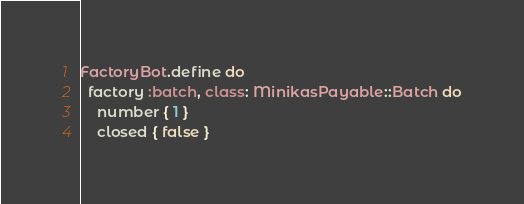Convert code to text. <code><loc_0><loc_0><loc_500><loc_500><_Ruby_>FactoryBot.define do
  factory :batch, class: MinikasPayable::Batch do
    number { 1 }
    closed { false }</code> 